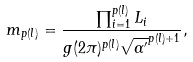<formula> <loc_0><loc_0><loc_500><loc_500>m _ { p ( l ) } = \frac { \prod _ { i = 1 } ^ { p ( l ) } L _ { i } } { g ( 2 \pi ) ^ { p ( l ) } { \sqrt { \alpha ^ { \prime } } } ^ { p ( l ) + 1 } } ,</formula> 